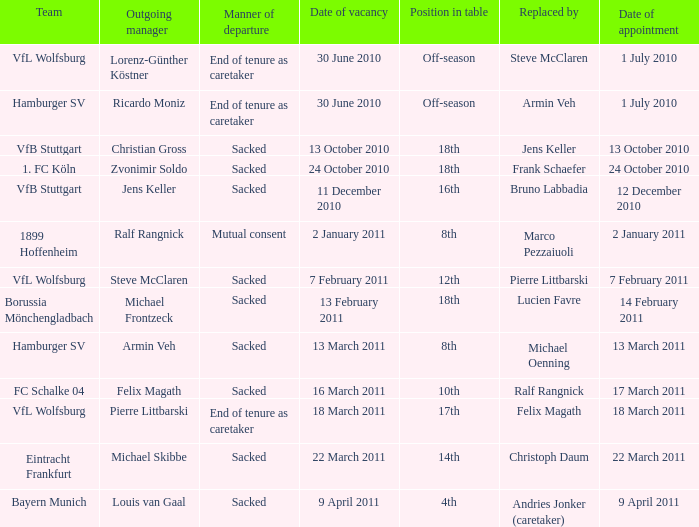When steve mcclaren is the replacer what is the manner of departure? End of tenure as caretaker. 